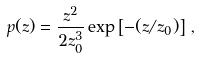<formula> <loc_0><loc_0><loc_500><loc_500>p ( z ) = \frac { z ^ { 2 } } { 2 z _ { 0 } ^ { 3 } } \exp \left [ - ( z / z _ { 0 } ) \right ] \, ,</formula> 